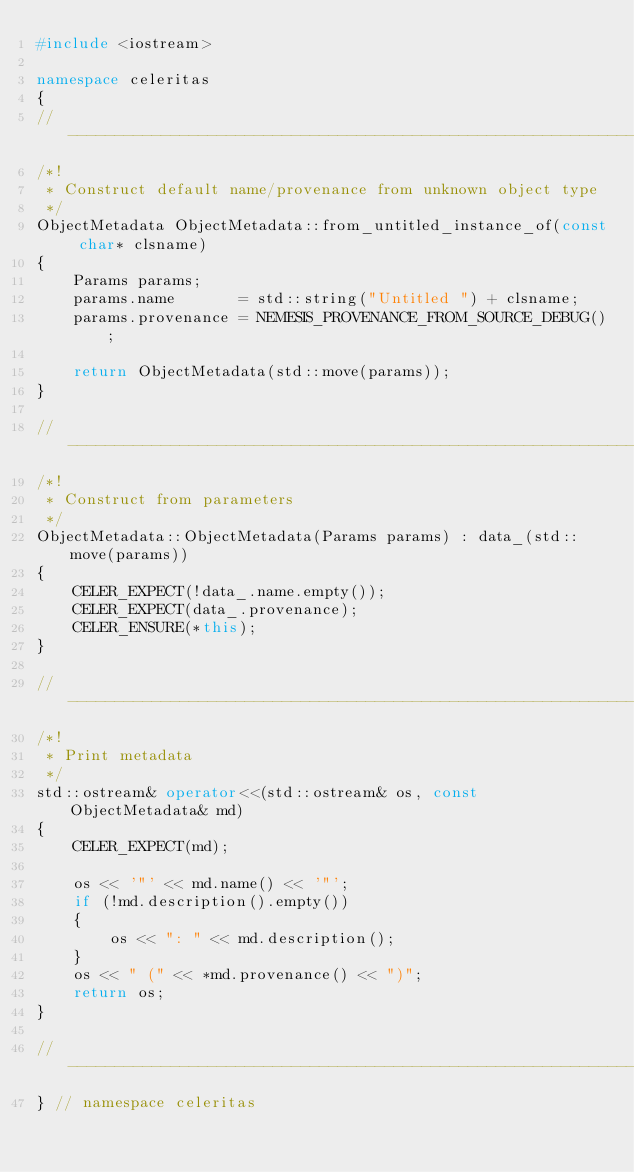<code> <loc_0><loc_0><loc_500><loc_500><_C++_>#include <iostream>

namespace celeritas
{
//---------------------------------------------------------------------------//
/*!
 * Construct default name/provenance from unknown object type
 */
ObjectMetadata ObjectMetadata::from_untitled_instance_of(const char* clsname)
{
    Params params;
    params.name       = std::string("Untitled ") + clsname;
    params.provenance = NEMESIS_PROVENANCE_FROM_SOURCE_DEBUG();

    return ObjectMetadata(std::move(params));
}

//---------------------------------------------------------------------------//
/*!
 * Construct from parameters
 */
ObjectMetadata::ObjectMetadata(Params params) : data_(std::move(params))
{
    CELER_EXPECT(!data_.name.empty());
    CELER_EXPECT(data_.provenance);
    CELER_ENSURE(*this);
}

//---------------------------------------------------------------------------//
/*!
 * Print metadata
 */
std::ostream& operator<<(std::ostream& os, const ObjectMetadata& md)
{
    CELER_EXPECT(md);

    os << '"' << md.name() << '"';
    if (!md.description().empty())
    {
        os << ": " << md.description();
    }
    os << " (" << *md.provenance() << ")";
    return os;
}

//---------------------------------------------------------------------------//
} // namespace celeritas
</code> 